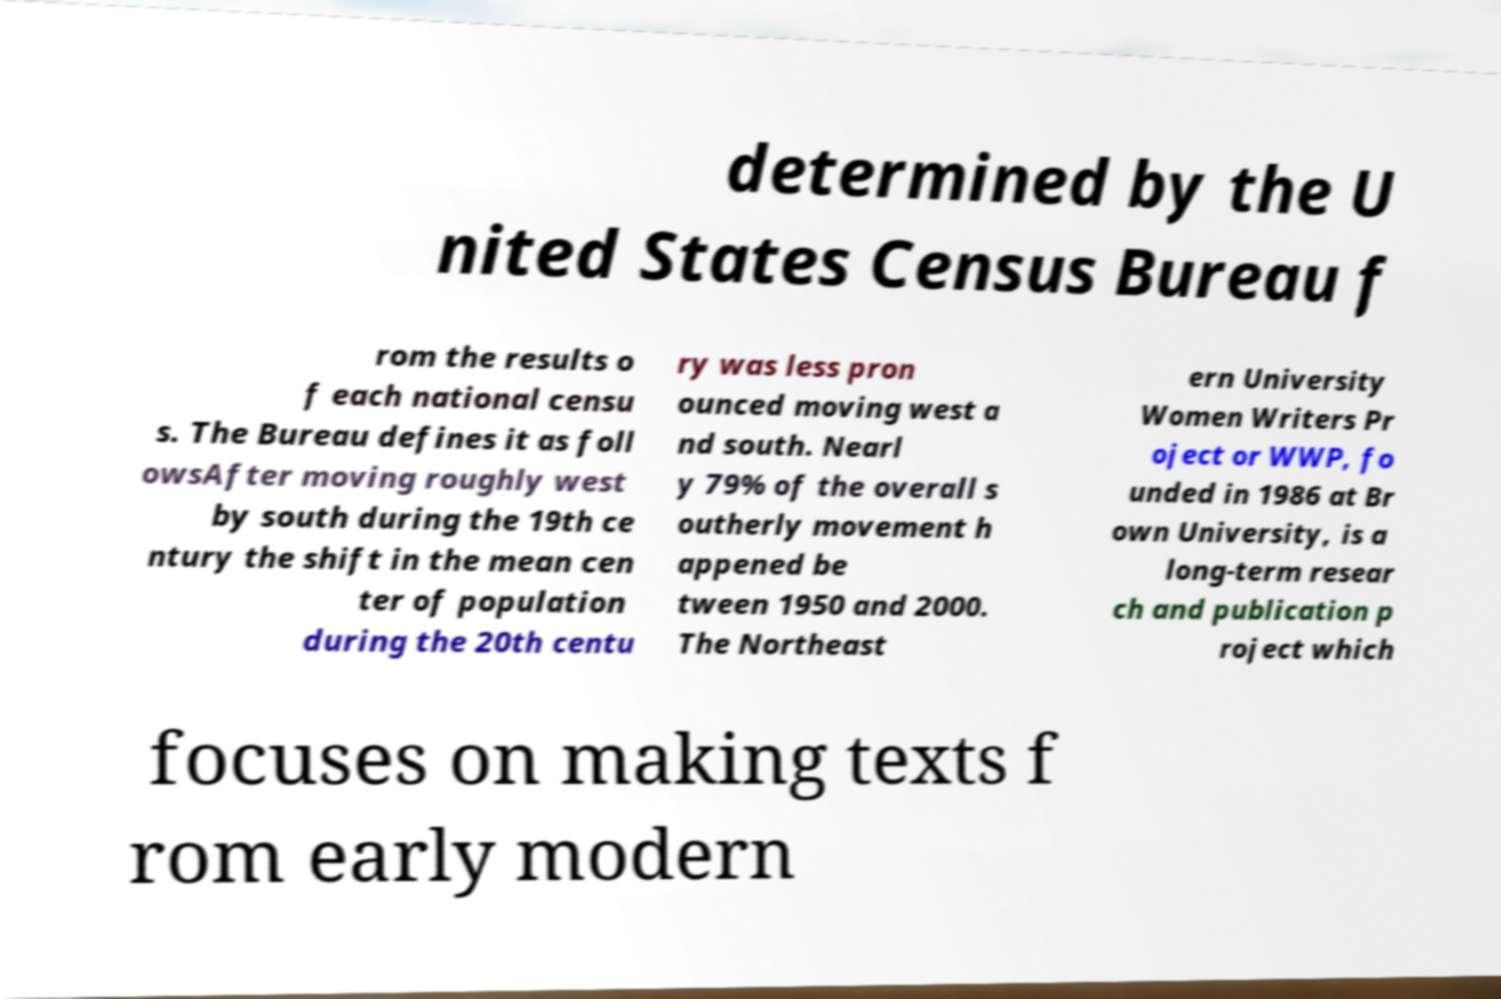Please identify and transcribe the text found in this image. determined by the U nited States Census Bureau f rom the results o f each national censu s. The Bureau defines it as foll owsAfter moving roughly west by south during the 19th ce ntury the shift in the mean cen ter of population during the 20th centu ry was less pron ounced moving west a nd south. Nearl y 79% of the overall s outherly movement h appened be tween 1950 and 2000. The Northeast ern University Women Writers Pr oject or WWP, fo unded in 1986 at Br own University, is a long-term resear ch and publication p roject which focuses on making texts f rom early modern 